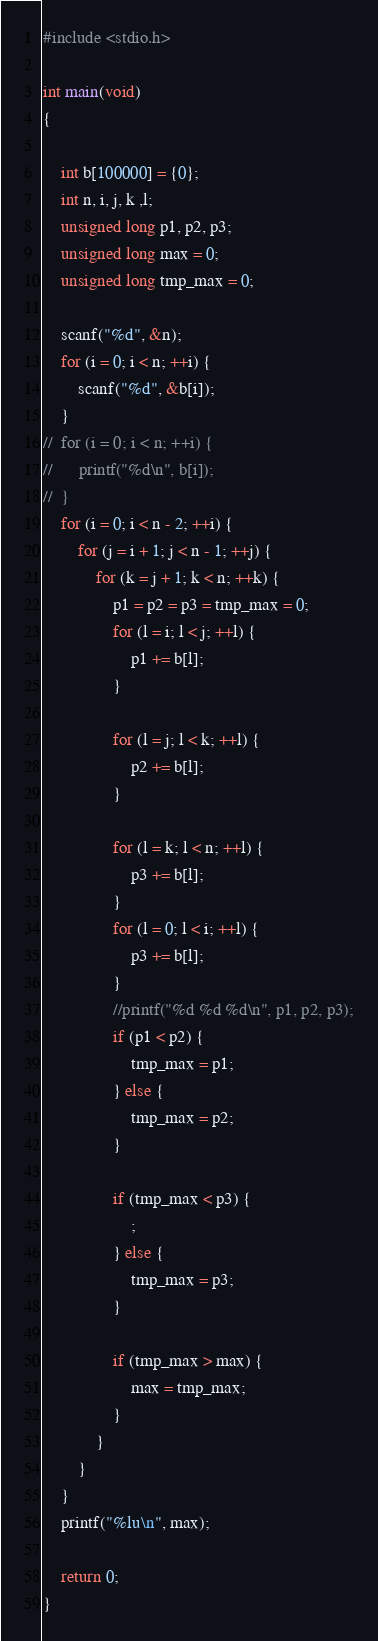<code> <loc_0><loc_0><loc_500><loc_500><_C_>#include <stdio.h>

int main(void)
{
	
	int b[100000] = {0};
	int n, i, j, k ,l;
	unsigned long p1, p2, p3;
	unsigned long max = 0;
	unsigned long tmp_max = 0;
	
	scanf("%d", &n);
	for (i = 0; i < n; ++i) {
		scanf("%d", &b[i]);
	}
//	for (i = 0; i < n; ++i) {
//		printf("%d\n", b[i]);
//	}
	for (i = 0; i < n - 2; ++i) {
		for (j = i + 1; j < n - 1; ++j) {
			for (k = j + 1; k < n; ++k) {
				p1 = p2 = p3 = tmp_max = 0;
				for (l = i; l < j; ++l) {
					p1 += b[l];
				}

				for (l = j; l < k; ++l) {
					p2 += b[l];
				}

				for (l = k; l < n; ++l) {
					p3 += b[l];
				}
				for (l = 0; l < i; ++l) {
					p3 += b[l];
				}
				//printf("%d %d %d\n", p1, p2, p3);
				if (p1 < p2) {
					tmp_max = p1;
				} else {
					tmp_max = p2;
				}

				if (tmp_max < p3) {
					;
				} else {
					tmp_max = p3;
				}

				if (tmp_max > max) {
					max = tmp_max;
				}
			}
		}
	}
	printf("%lu\n", max);
	
	return 0;
}</code> 